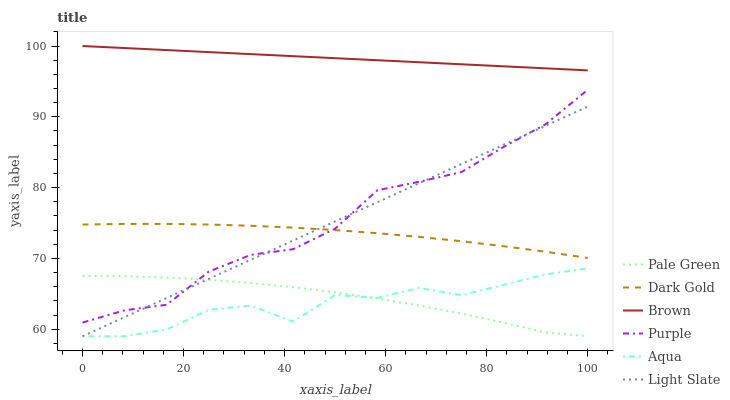Does Aqua have the minimum area under the curve?
Answer yes or no. Yes. Does Brown have the maximum area under the curve?
Answer yes or no. Yes. Does Dark Gold have the minimum area under the curve?
Answer yes or no. No. Does Dark Gold have the maximum area under the curve?
Answer yes or no. No. Is Light Slate the smoothest?
Answer yes or no. Yes. Is Aqua the roughest?
Answer yes or no. Yes. Is Dark Gold the smoothest?
Answer yes or no. No. Is Dark Gold the roughest?
Answer yes or no. No. Does Aqua have the lowest value?
Answer yes or no. Yes. Does Dark Gold have the lowest value?
Answer yes or no. No. Does Brown have the highest value?
Answer yes or no. Yes. Does Dark Gold have the highest value?
Answer yes or no. No. Is Pale Green less than Brown?
Answer yes or no. Yes. Is Dark Gold greater than Aqua?
Answer yes or no. Yes. Does Purple intersect Light Slate?
Answer yes or no. Yes. Is Purple less than Light Slate?
Answer yes or no. No. Is Purple greater than Light Slate?
Answer yes or no. No. Does Pale Green intersect Brown?
Answer yes or no. No. 